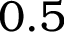<formula> <loc_0><loc_0><loc_500><loc_500>0 . 5</formula> 